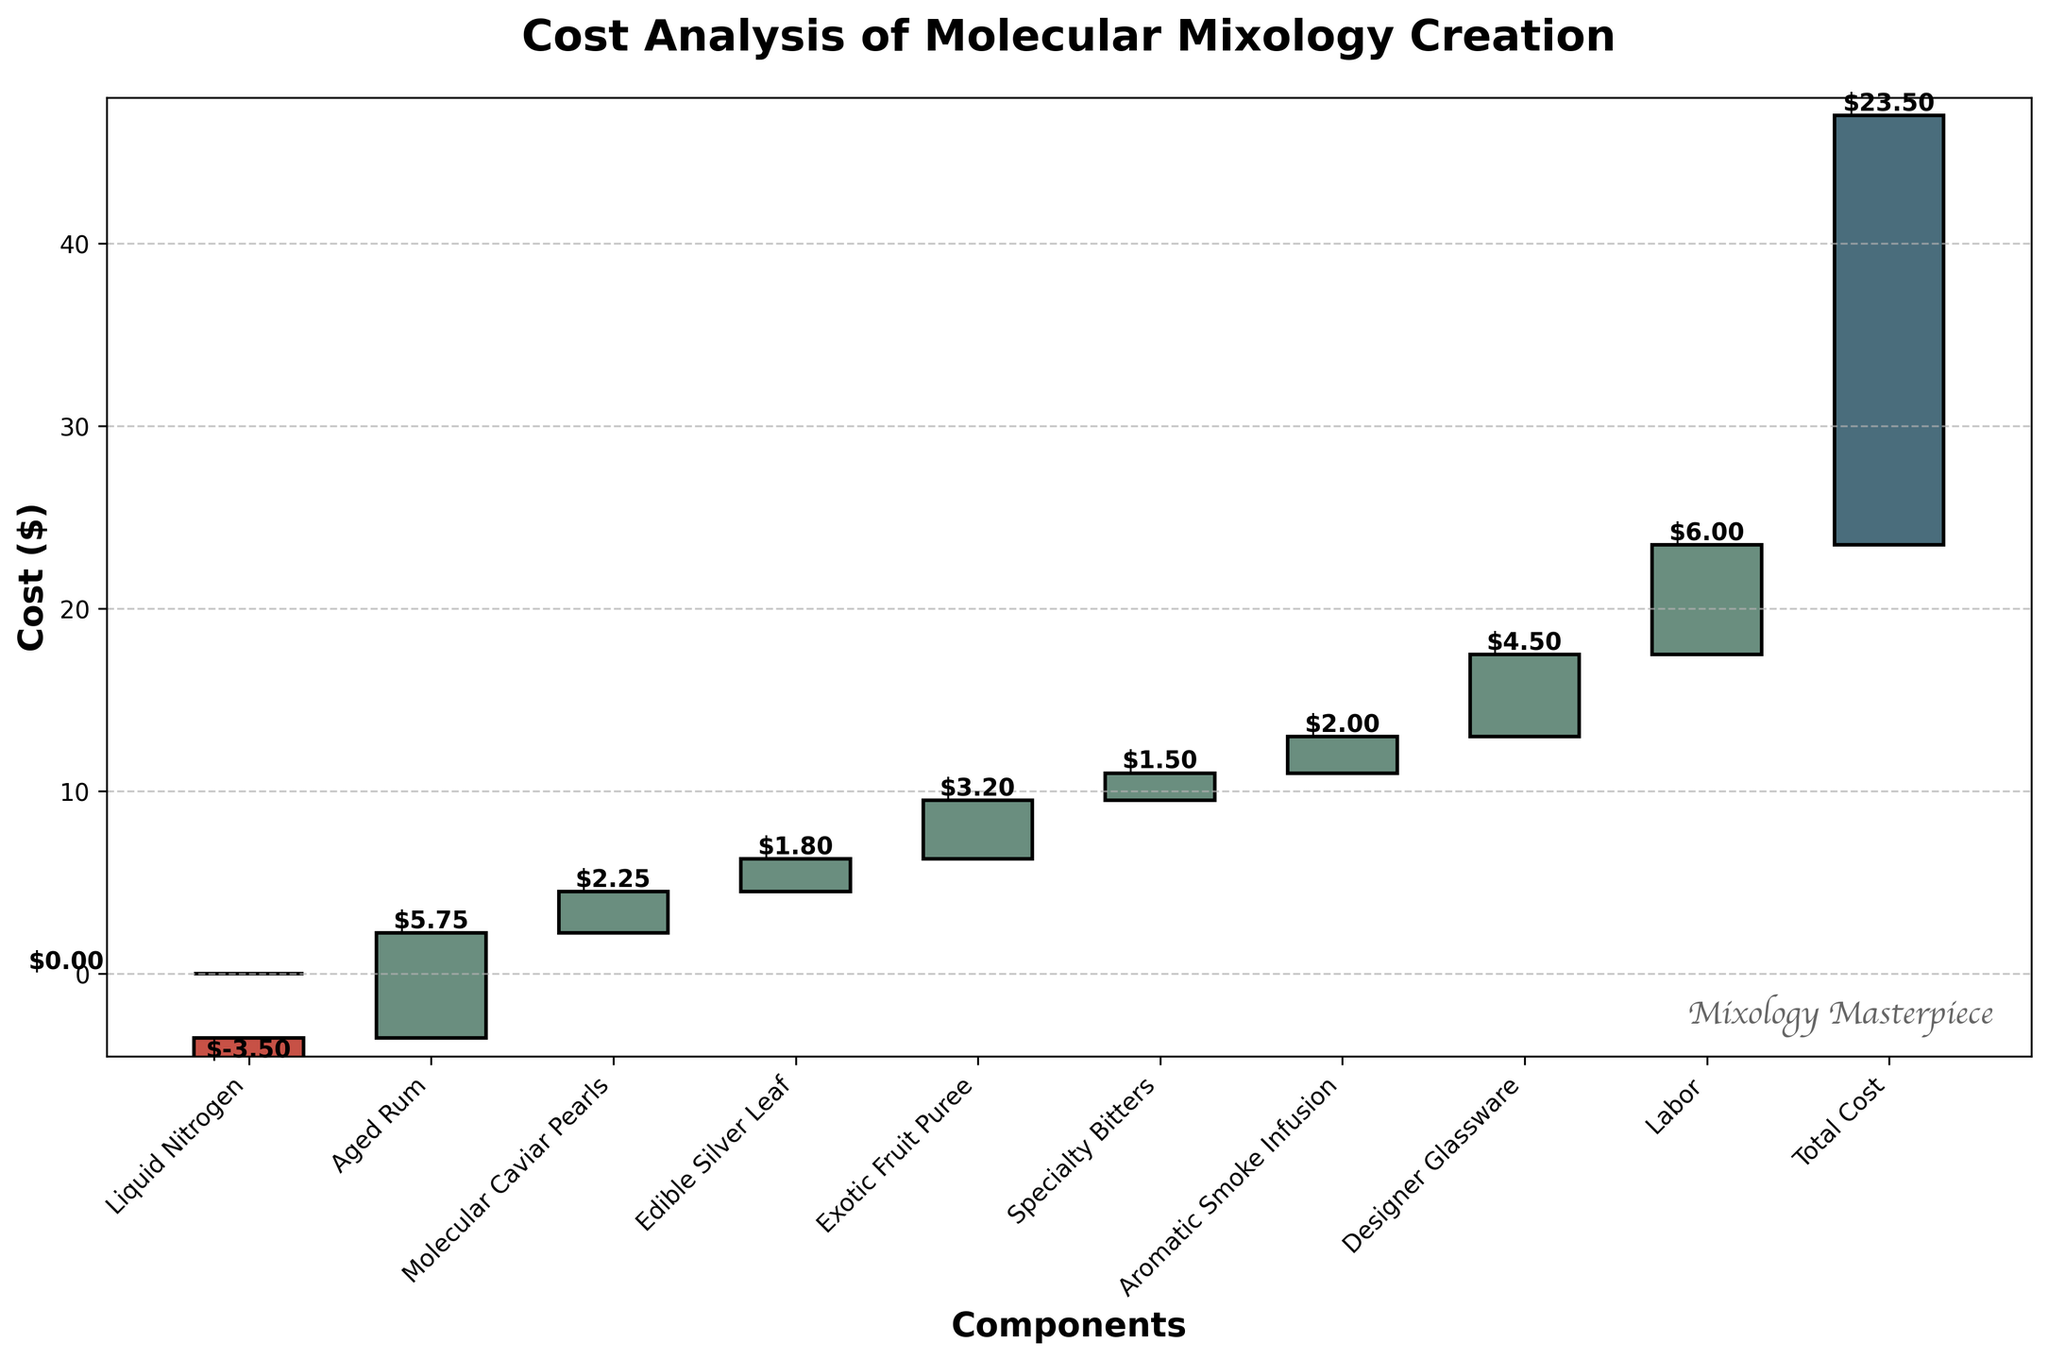What is the title of the chart? The title of the chart is located at the top and describes the main topic or focus of the chart.
Answer: Cost Analysis of Molecular Mixology Creation What color are the negative value bars representing costs? The negative value bars in the waterfall chart are visually distinct, indicated by a different color (likely a shade of red) compared to the other bars.
Answer: Red How many components contribute positively to the total cost? By looking at the positive values on the chart, we can count the number of segments that increase the total cost.
Answer: 8 Which ingredient has the highest individual cost? To determine which component has the highest individual cost, check the bar that rises the most among the positive values.
Answer: Labor What's the total cumulative cost displayed at the end of the chart? The final bar in the waterfall chart showcases the total cumulative cost after accounting for all individual components.
Answer: 23.50 What is the contribution of "Liquid Nitrogen" in the cost analysis? The contribution of "Liquid Nitrogen" is found by observing its specific bar, which should be marked with a negative value.
Answer: -3.50 How much more cost does the "Designer Glassware" add compared to "Specialty Bitters"? First, identify the cost values for both components and then compute the difference between them: Designer Glassware ($4.50) - Specialty Bitters ($1.50) = $3.00.
Answer: 3.00 What's the net positive contribution of "Aged Rum" and "Exotic Fruit Puree"? Sum the individual contributions of "Aged Rum" ($5.75) and "Exotic Fruit Puree" ($3.20) to get the net positive contribution: $5.75 + $3.20 = $8.95.
Answer: 8.95 Comparing "Molecular Caviar Pearls" and "Edible Silver Leaf," which one has a higher cost and by how much? Locate the bars for both ingredients and compute the difference: Molecular Caviar Pearls ($2.25) - Edible Silver Leaf ($1.80) = $0.45.
Answer: Molecular Caviar Pearls, 0.45 What is the average cost contribution of all components excluding "Starting Cost" and "Total Cost"? Sum the costs of all components and divide by the number of components involved: (-3.50 + 5.75 + 2.25 + 1.80 + 3.20 + 1.50 + 2.00 + 4.50 + 6.00) / 9 = (23.50 / 9) = $2.61.
Answer: 2.61 